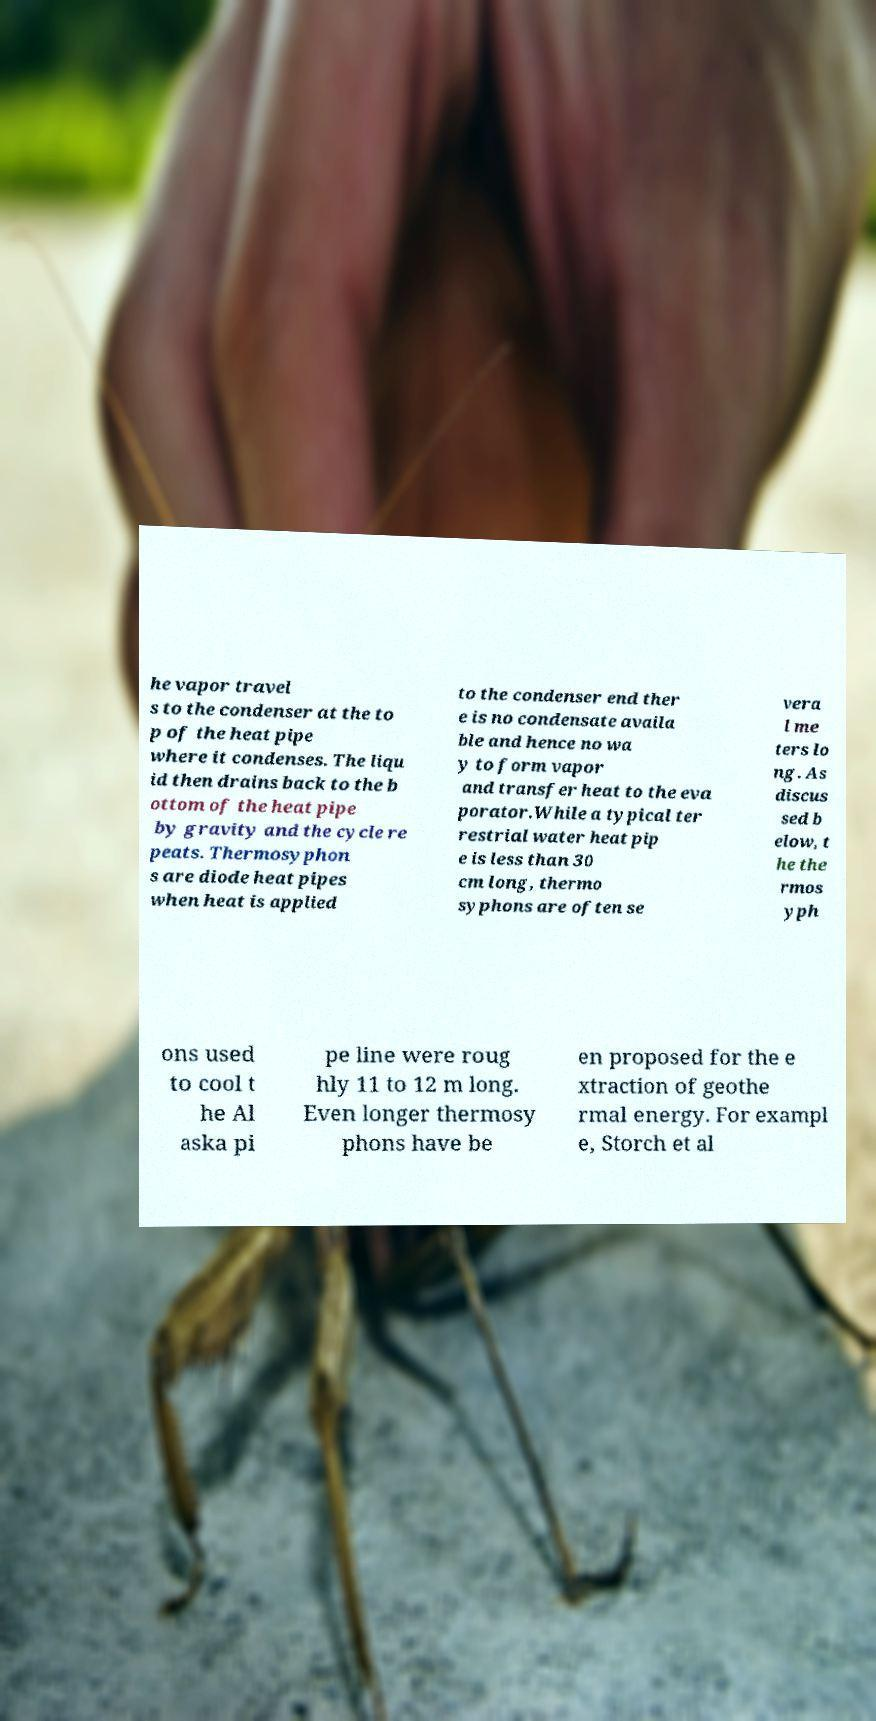There's text embedded in this image that I need extracted. Can you transcribe it verbatim? he vapor travel s to the condenser at the to p of the heat pipe where it condenses. The liqu id then drains back to the b ottom of the heat pipe by gravity and the cycle re peats. Thermosyphon s are diode heat pipes when heat is applied to the condenser end ther e is no condensate availa ble and hence no wa y to form vapor and transfer heat to the eva porator.While a typical ter restrial water heat pip e is less than 30 cm long, thermo syphons are often se vera l me ters lo ng. As discus sed b elow, t he the rmos yph ons used to cool t he Al aska pi pe line were roug hly 11 to 12 m long. Even longer thermosy phons have be en proposed for the e xtraction of geothe rmal energy. For exampl e, Storch et al 